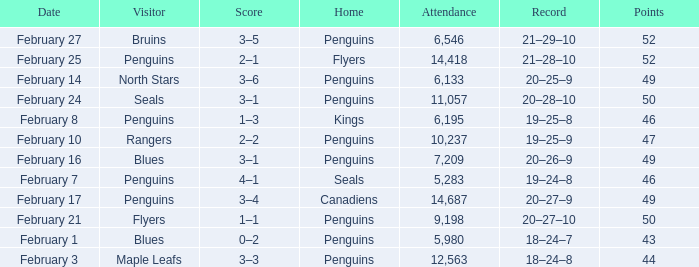Can you parse all the data within this table? {'header': ['Date', 'Visitor', 'Score', 'Home', 'Attendance', 'Record', 'Points'], 'rows': [['February 27', 'Bruins', '3–5', 'Penguins', '6,546', '21–29–10', '52'], ['February 25', 'Penguins', '2–1', 'Flyers', '14,418', '21–28–10', '52'], ['February 14', 'North Stars', '3–6', 'Penguins', '6,133', '20–25–9', '49'], ['February 24', 'Seals', '3–1', 'Penguins', '11,057', '20–28–10', '50'], ['February 8', 'Penguins', '1–3', 'Kings', '6,195', '19–25–8', '46'], ['February 10', 'Rangers', '2–2', 'Penguins', '10,237', '19–25–9', '47'], ['February 16', 'Blues', '3–1', 'Penguins', '7,209', '20–26–9', '49'], ['February 7', 'Penguins', '4–1', 'Seals', '5,283', '19–24–8', '46'], ['February 17', 'Penguins', '3–4', 'Canadiens', '14,687', '20–27–9', '49'], ['February 21', 'Flyers', '1–1', 'Penguins', '9,198', '20–27–10', '50'], ['February 1', 'Blues', '0–2', 'Penguins', '5,980', '18–24–7', '43'], ['February 3', 'Maple Leafs', '3–3', 'Penguins', '12,563', '18–24–8', '44']]} Home of kings had what score? 1–3. 